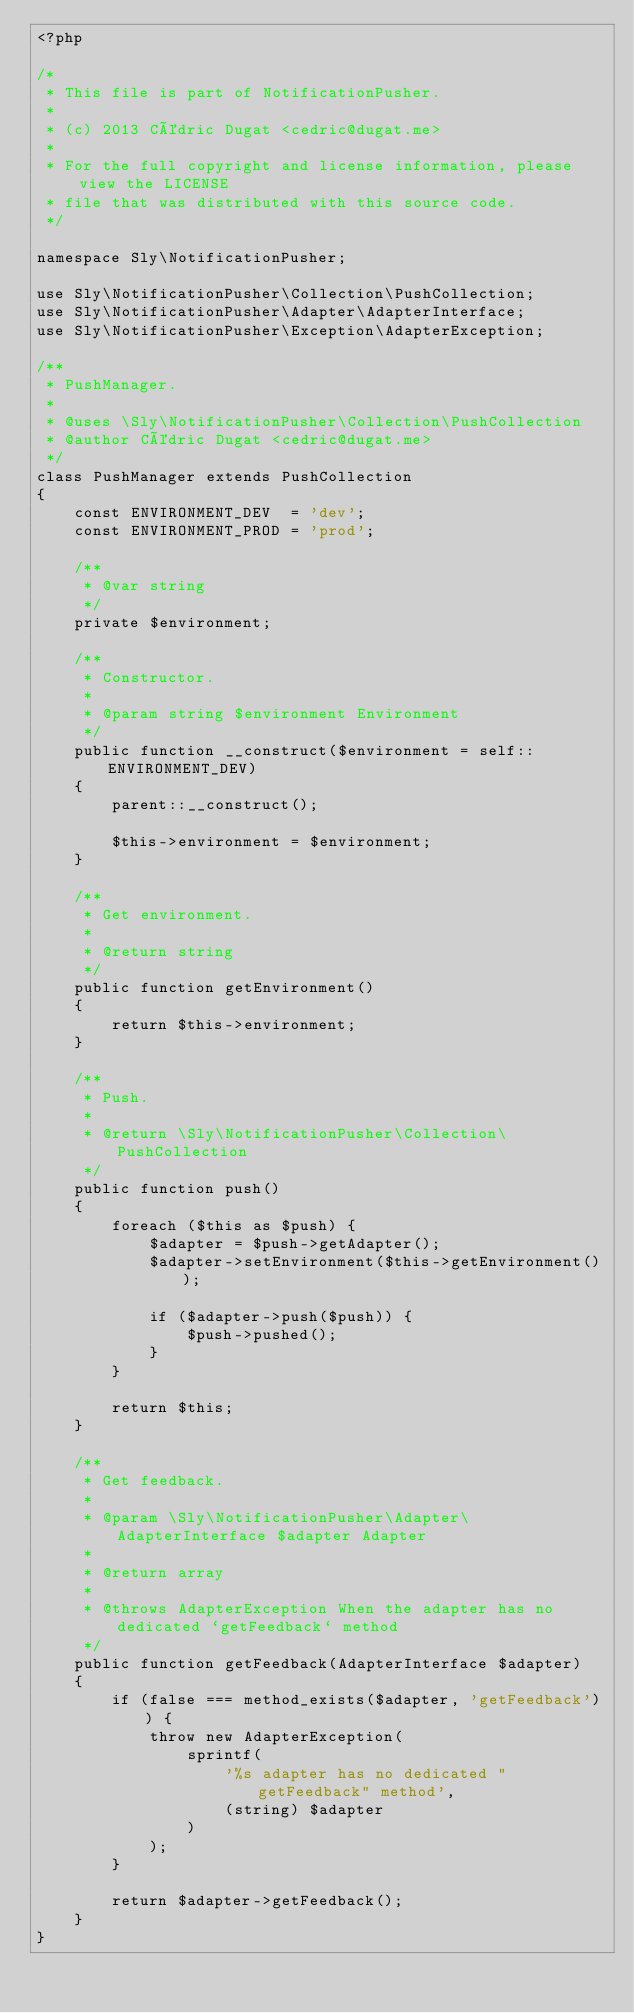<code> <loc_0><loc_0><loc_500><loc_500><_PHP_><?php

/*
 * This file is part of NotificationPusher.
 *
 * (c) 2013 Cédric Dugat <cedric@dugat.me>
 *
 * For the full copyright and license information, please view the LICENSE
 * file that was distributed with this source code.
 */

namespace Sly\NotificationPusher;

use Sly\NotificationPusher\Collection\PushCollection;
use Sly\NotificationPusher\Adapter\AdapterInterface;
use Sly\NotificationPusher\Exception\AdapterException;

/**
 * PushManager.
 *
 * @uses \Sly\NotificationPusher\Collection\PushCollection
 * @author Cédric Dugat <cedric@dugat.me>
 */
class PushManager extends PushCollection
{
    const ENVIRONMENT_DEV  = 'dev';
    const ENVIRONMENT_PROD = 'prod';

    /**
     * @var string
     */
    private $environment;

    /**
     * Constructor.
     *
     * @param string $environment Environment
     */
    public function __construct($environment = self::ENVIRONMENT_DEV)
    {
        parent::__construct();

        $this->environment = $environment;
    }

    /**
     * Get environment.
     *
     * @return string
     */
    public function getEnvironment()
    {
        return $this->environment;
    }

    /**
     * Push.
     *
     * @return \Sly\NotificationPusher\Collection\PushCollection
     */
    public function push()
    {
        foreach ($this as $push) {
            $adapter = $push->getAdapter();
            $adapter->setEnvironment($this->getEnvironment());

            if ($adapter->push($push)) {
                $push->pushed();
            }
        }

        return $this;
    }

    /**
     * Get feedback.
     *
     * @param \Sly\NotificationPusher\Adapter\AdapterInterface $adapter Adapter
     *
     * @return array
     *
     * @throws AdapterException When the adapter has no dedicated `getFeedback` method
     */
    public function getFeedback(AdapterInterface $adapter)
    {
        if (false === method_exists($adapter, 'getFeedback')) {
            throw new AdapterException(
                sprintf(
                    '%s adapter has no dedicated "getFeedback" method',
                    (string) $adapter
                )
            );
        }

        return $adapter->getFeedback();
    }
}
</code> 